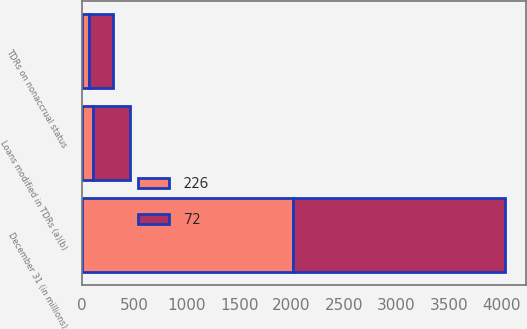Convert chart. <chart><loc_0><loc_0><loc_500><loc_500><stacked_bar_chart><ecel><fcel>December 31 (in millions)<fcel>Loans modified in TDRs (a)(b)<fcel>TDRs on nonaccrual status<nl><fcel>226<fcel>2017<fcel>102<fcel>72<nl><fcel>72<fcel>2016<fcel>362<fcel>226<nl></chart> 